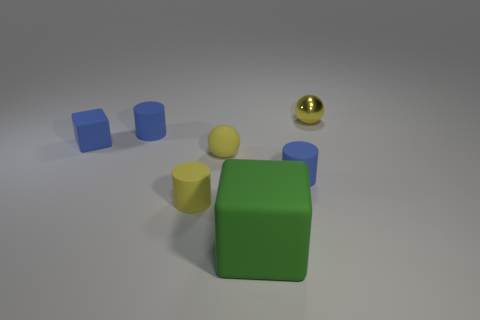There is another sphere that is the same color as the tiny metal ball; what material is it?
Make the answer very short. Rubber. What is the shape of the yellow object that is right of the large block that is in front of the ball that is on the left side of the tiny yellow shiny object?
Give a very brief answer. Sphere. Do the tiny yellow shiny thing and the small blue thing that is in front of the small block have the same shape?
Your answer should be compact. No. The metal object that is the same color as the small rubber ball is what shape?
Provide a short and direct response. Sphere. There is a blue cylinder in front of the yellow rubber object behind the tiny yellow cylinder; what number of cubes are on the right side of it?
Your response must be concise. 0. There is a metallic ball that is the same size as the yellow matte cylinder; what color is it?
Your response must be concise. Yellow. There is a yellow thing that is behind the small yellow sphere left of the big green block; what size is it?
Offer a very short reply. Small. There is a matte sphere that is the same color as the tiny metallic object; what size is it?
Give a very brief answer. Small. What number of small blocks are there?
Your answer should be compact. 1. Do the matte sphere and the blue block have the same size?
Ensure brevity in your answer.  Yes. 